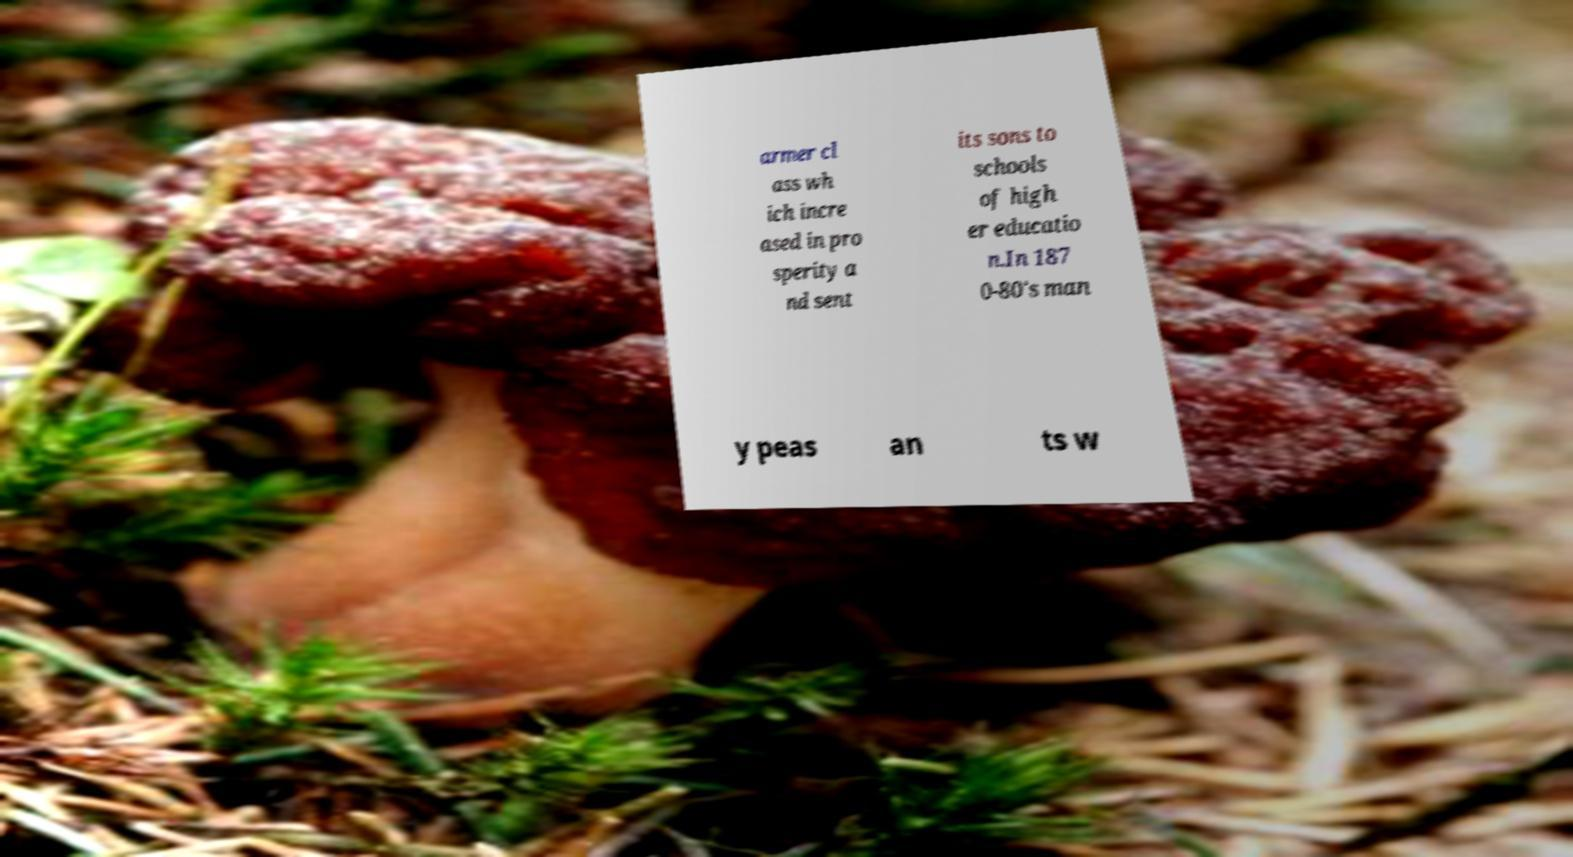Could you assist in decoding the text presented in this image and type it out clearly? armer cl ass wh ich incre ased in pro sperity a nd sent its sons to schools of high er educatio n.In 187 0-80's man y peas an ts w 